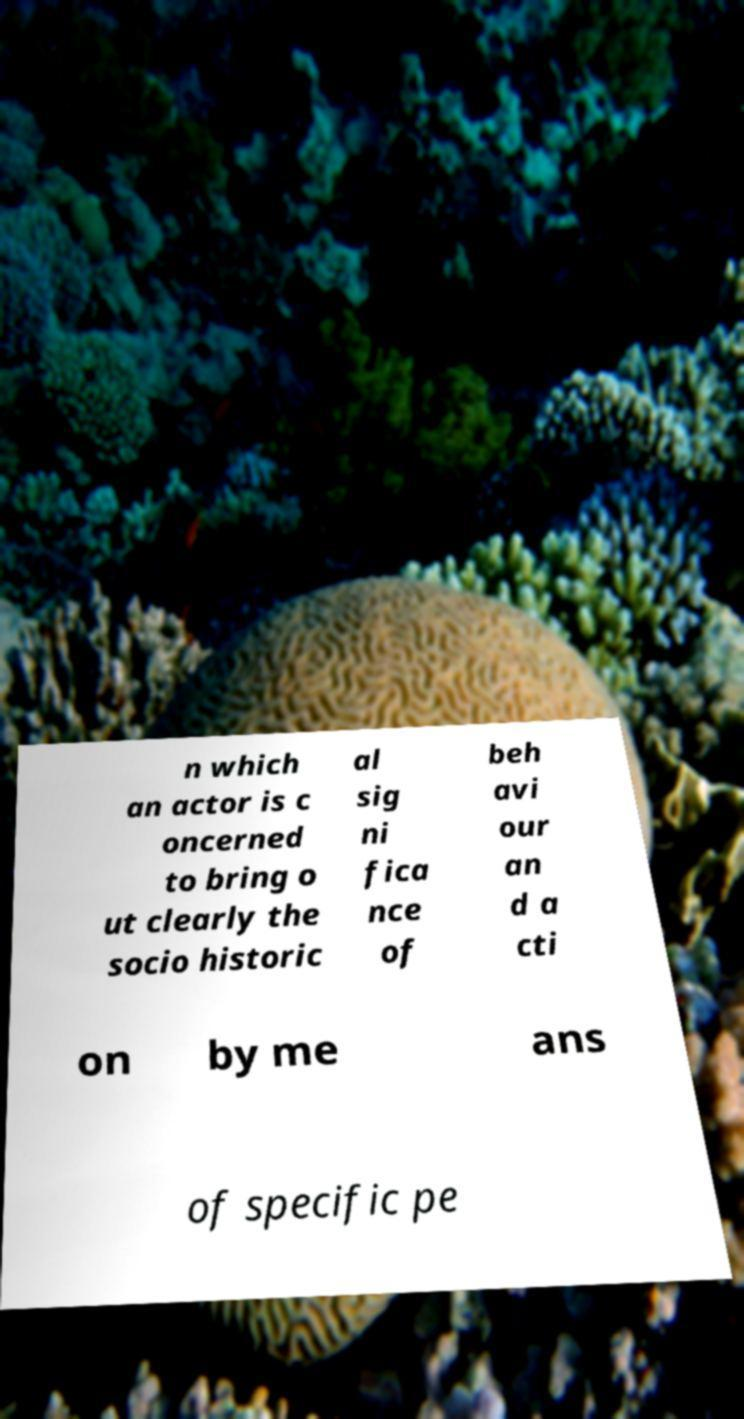Could you assist in decoding the text presented in this image and type it out clearly? n which an actor is c oncerned to bring o ut clearly the socio historic al sig ni fica nce of beh avi our an d a cti on by me ans of specific pe 